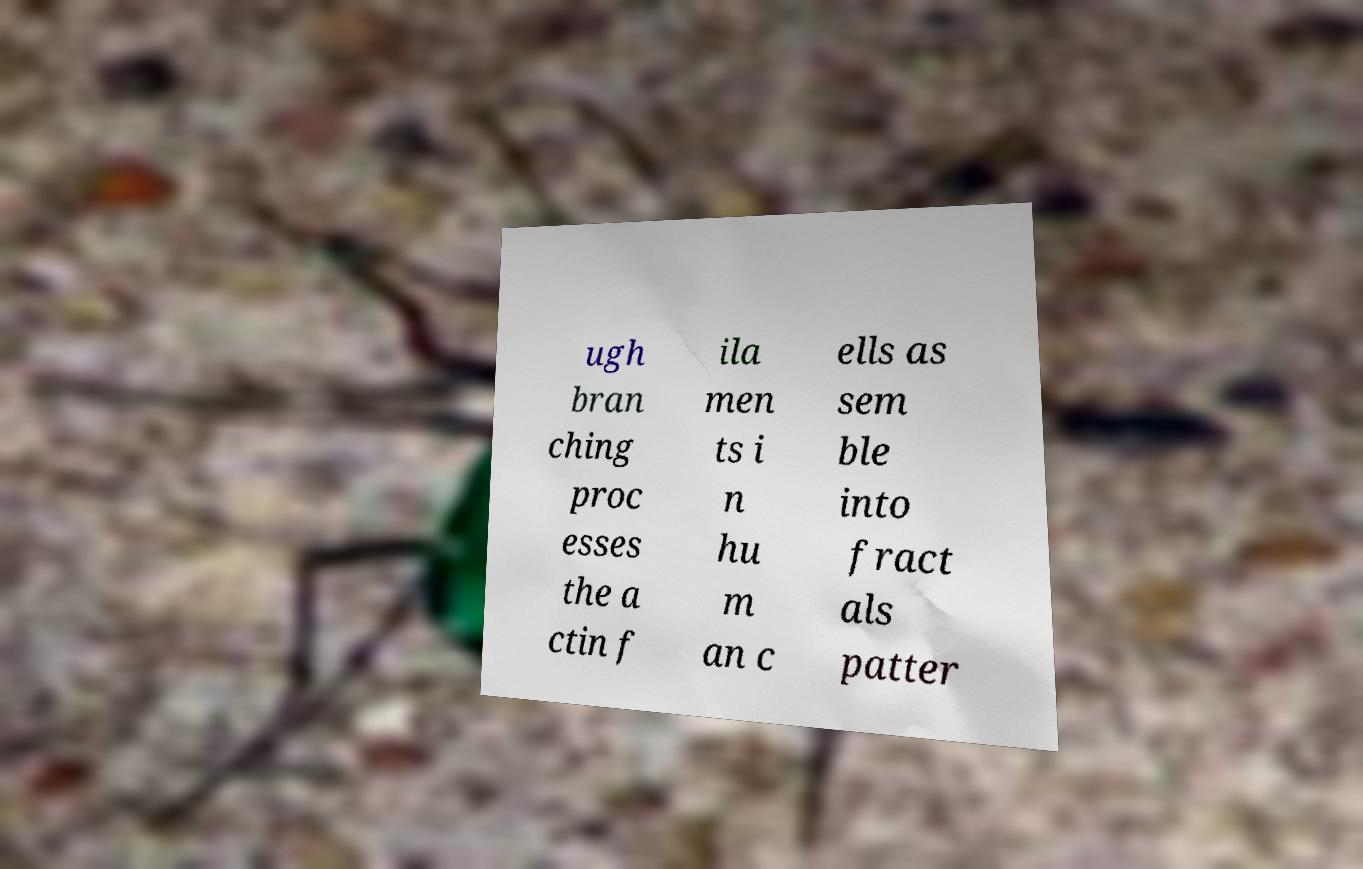Please identify and transcribe the text found in this image. ugh bran ching proc esses the a ctin f ila men ts i n hu m an c ells as sem ble into fract als patter 